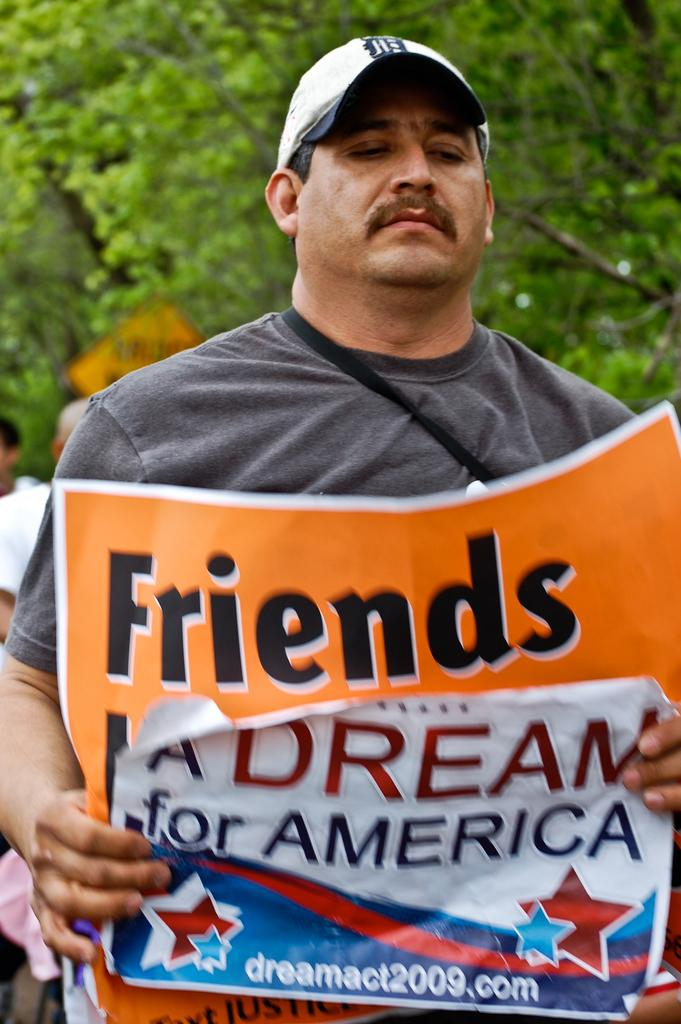<image>
Relay a brief, clear account of the picture shown. A man holding a poster reading A dream for America. 